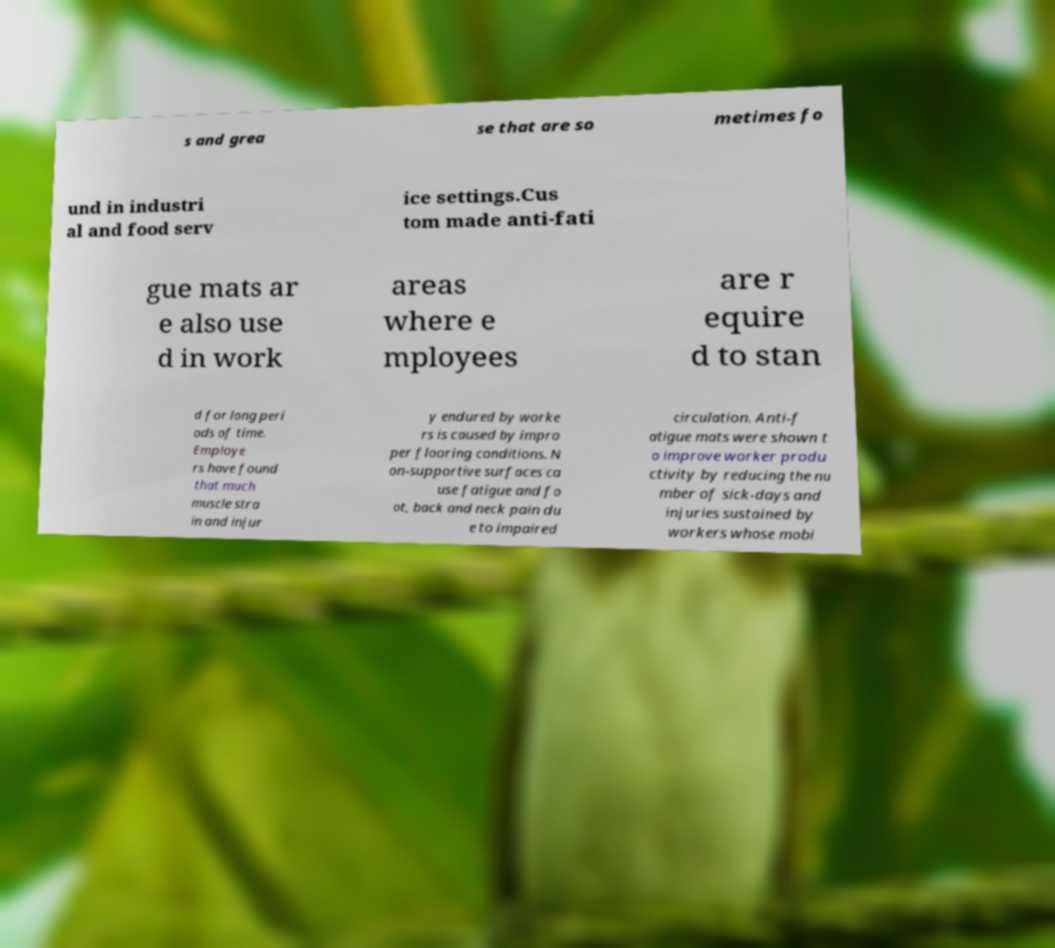Can you read and provide the text displayed in the image?This photo seems to have some interesting text. Can you extract and type it out for me? s and grea se that are so metimes fo und in industri al and food serv ice settings.Cus tom made anti-fati gue mats ar e also use d in work areas where e mployees are r equire d to stan d for long peri ods of time. Employe rs have found that much muscle stra in and injur y endured by worke rs is caused by impro per flooring conditions. N on-supportive surfaces ca use fatigue and fo ot, back and neck pain du e to impaired circulation. Anti-f atigue mats were shown t o improve worker produ ctivity by reducing the nu mber of sick-days and injuries sustained by workers whose mobi 